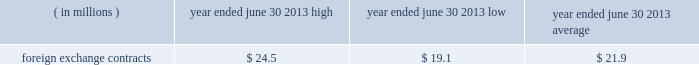Currencies of major industrial countries .
We may also enter into foreign currency option contracts to hedge anticipated transactions where there is a high probability that anticipated exposures will materialize .
The foreign currency forward contracts entered into to hedge antici- pated transactions have been designated as foreign currency cash-flow hedges and have varying maturities through the end of march 2015 .
Hedge effectiveness of foreign currency forward contracts is based on a hypo- thetical derivative methodology and excludes the portion of fair value attributable to the spot-forward difference which is recorded in current-period earnings .
Hedge effectiveness of foreign currency option contracts is based on a dollar offset methodology .
The ineffective portion of both foreign currency forward and option con- tracts is recorded in current-period earnings .
For hedge contracts that are no longer deemed highly effective , hedge accounting is discontinued and gains and losses accumulated in other comprehensive income ( loss ) are reclassified to earnings when the underlying forecasted transaction occurs .
If it is probable that the forecasted transaction will no longer occur , then any gains or losses in accumulated other comprehensive income ( loss ) are reclassified to current-period earnings .
As of june 30 , 2013 , these foreign currency cash-flow hedges were highly effective in all material respects .
At june 30 , 2013 , we had foreign currency forward contracts in the amount of $ 1579.6 million .
The foreign currencies included in foreign currency forward contracts ( notional value stated in u.s .
Dollars ) are principally the british pound ( $ 426.2 million ) , euro ( $ 268.8 million ) , canadian dollar ( $ 198.6 million ) , swiss franc ( $ 111.5 mil- lion ) , australian dollar ( $ 92.1 million ) , thailand baht ( $ 75.5 million ) and hong kong dollar ( $ 58.1 million ) .
Credit risk as a matter of policy , we only enter into derivative con- tracts with counterparties that have a long-term credit rat- ing of at least a- or higher by at least two nationally recognized rating agencies .
The counterparties to these contracts are major financial institutions .
Exposure to credit risk in the event of nonperformance by any of the counterparties is limited to the gross fair value of con- tracts in asset positions , which totaled $ 21.7 million at june 30 , 2013 .
To manage this risk , we have established counterparty credit guidelines that are continually moni- tored .
Accordingly , management believes risk of loss under these hedging contracts is remote .
Certain of our derivative financial instruments contain credit-risk-related contingent features .
At june 30 , 2013 , we were in a net asset position for certain derivative contracts that contain such features with two counter- parties .
The fair value of those contracts as of june 30 , 2013 was approximately $ 4.6 million .
As of june 30 , 2013 , we were in compliance with such credit-risk-related contingent features .
Market risk we use a value-at-risk model to assess the market risk of our derivative financial instruments .
Value-at-risk repre- sents the potential losses for an instrument or portfolio from adverse changes in market factors for a specified time period and confidence level .
We estimate value-at- risk across all of our derivative financial instruments using a model with historical volatilities and correlations calcu- lated over the past 250-day period .
The high , low and average measured value-at-risk during fiscal 2013 related to our foreign exchange contracts is as follows: .
Foreign exchange contracts $ 24.5 $ 19.1 $ 21.9 the model estimates were made assuming normal market conditions and a 95 percent confidence level .
We used a statistical simulation model that valued our derivative financial instruments against one thousand randomly gen- erated market price paths .
Our calculated value-at-risk exposure represents an estimate of reasonably possible net losses that would be recognized on our portfolio of derivative financial instruments assuming hypothetical movements in future market rates and is not necessarily indicative of actual results , which may or may not occur .
It does not represent the maximum possible loss or any expected loss that may occur , since actual future gains and losses will differ from those estimated , based upon actual fluctuations in market rates , operating exposures , and the timing thereof , and changes in our portfolio of derivative financial instruments during the year .
We believe , however , that any such loss incurred would be offset by the effects of market rate movements on the respective underlying transactions for which the deriva- tive financial instrument was intended .
Off-balance sheet arrangements we do not maintain any off-balance sheet arrangements , transactions , obligations or other relationships with unconsolidated entities , other than operating leases , that would be expected to have a material current or future effect upon our financial condition or results of operations .
The est{e lauder companies inc .
135 .
Considering the year 2013 , what is the variation between the fair value of the foreign exchange contracts and its high measured value-at-risk? 
Rationale: it is the difference between those values .
Computations: (24.5 - 4.6)
Answer: 19.9. 